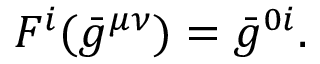<formula> <loc_0><loc_0><loc_500><loc_500>{ } F ^ { i } ( { \bar { g } } ^ { \mu \nu } ) = { \bar { g } } ^ { 0 i } .</formula> 